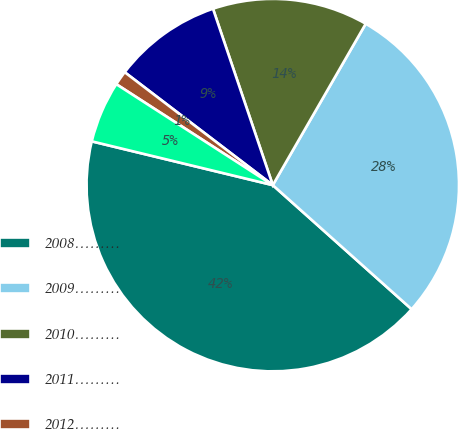Convert chart. <chart><loc_0><loc_0><loc_500><loc_500><pie_chart><fcel>2008………<fcel>2009………<fcel>2010………<fcel>2011………<fcel>2012………<fcel>2013 and thereafter<nl><fcel>42.17%<fcel>28.29%<fcel>13.52%<fcel>9.43%<fcel>1.25%<fcel>5.34%<nl></chart> 